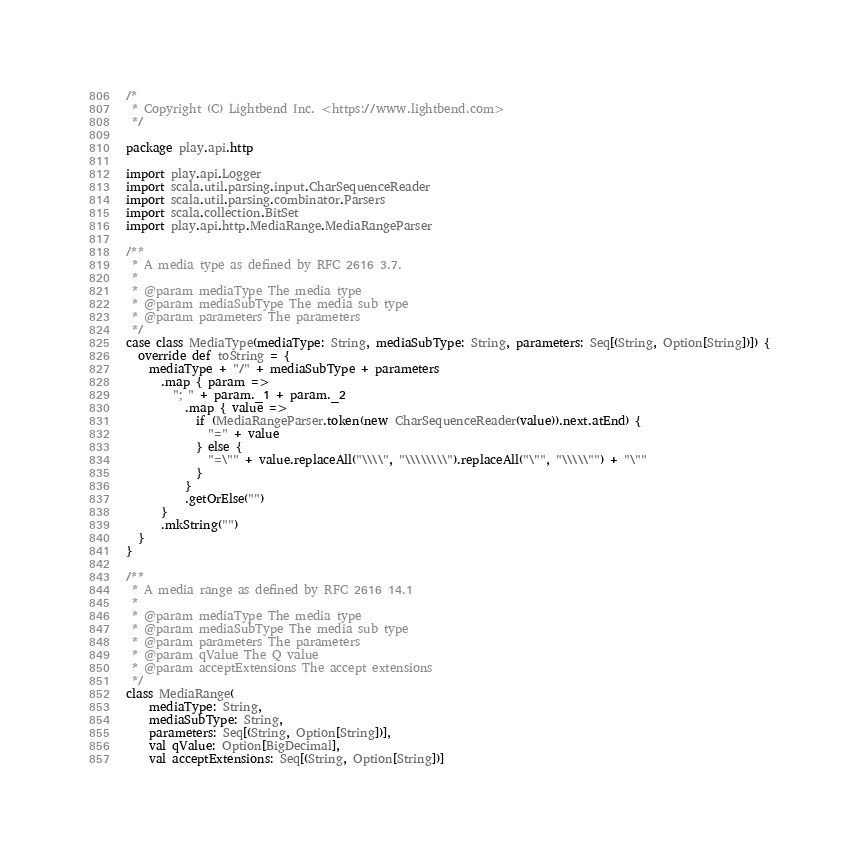Convert code to text. <code><loc_0><loc_0><loc_500><loc_500><_Scala_>/*
 * Copyright (C) Lightbend Inc. <https://www.lightbend.com>
 */

package play.api.http

import play.api.Logger
import scala.util.parsing.input.CharSequenceReader
import scala.util.parsing.combinator.Parsers
import scala.collection.BitSet
import play.api.http.MediaRange.MediaRangeParser

/**
 * A media type as defined by RFC 2616 3.7.
 *
 * @param mediaType The media type
 * @param mediaSubType The media sub type
 * @param parameters The parameters
 */
case class MediaType(mediaType: String, mediaSubType: String, parameters: Seq[(String, Option[String])]) {
  override def toString = {
    mediaType + "/" + mediaSubType + parameters
      .map { param =>
        "; " + param._1 + param._2
          .map { value =>
            if (MediaRangeParser.token(new CharSequenceReader(value)).next.atEnd) {
              "=" + value
            } else {
              "=\"" + value.replaceAll("\\\\", "\\\\\\\\").replaceAll("\"", "\\\\\"") + "\""
            }
          }
          .getOrElse("")
      }
      .mkString("")
  }
}

/**
 * A media range as defined by RFC 2616 14.1
 *
 * @param mediaType The media type
 * @param mediaSubType The media sub type
 * @param parameters The parameters
 * @param qValue The Q value
 * @param acceptExtensions The accept extensions
 */
class MediaRange(
    mediaType: String,
    mediaSubType: String,
    parameters: Seq[(String, Option[String])],
    val qValue: Option[BigDecimal],
    val acceptExtensions: Seq[(String, Option[String])]</code> 